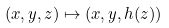Convert formula to latex. <formula><loc_0><loc_0><loc_500><loc_500>( x , y , z ) \mapsto ( x , y , h ( z ) )</formula> 